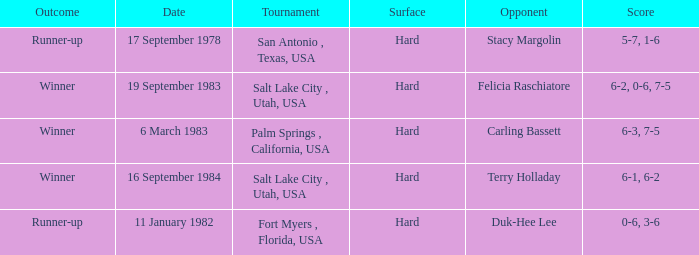What was the outcome of the game against duk-hee lee? 0-6, 3-6. 